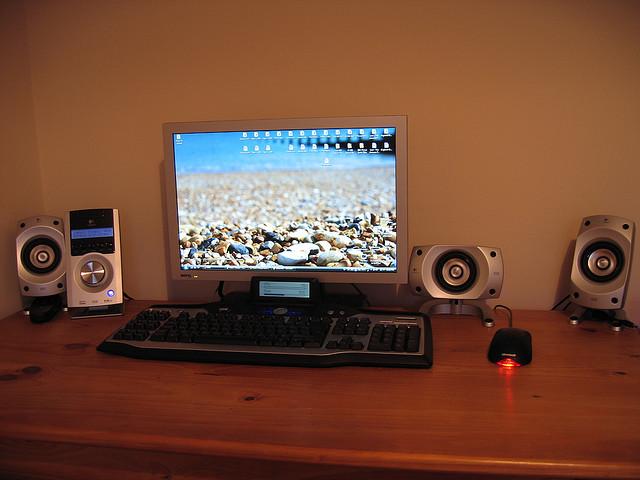Is this a a TV or Computer Monitor?
Be succinct. Computer. Is that a wireless computer mouse?
Short answer required. No. How many mice are in this photo?
Be succinct. 1. Is there a mousepad under the mouse?
Concise answer only. No. How many monitors are on top of the desk?
Answer briefly. 1. Is this a laptop computer?
Give a very brief answer. No. Is this a desktop computer?
Keep it brief. Yes. What is sitting on either side of the computer?
Quick response, please. Speakers. 